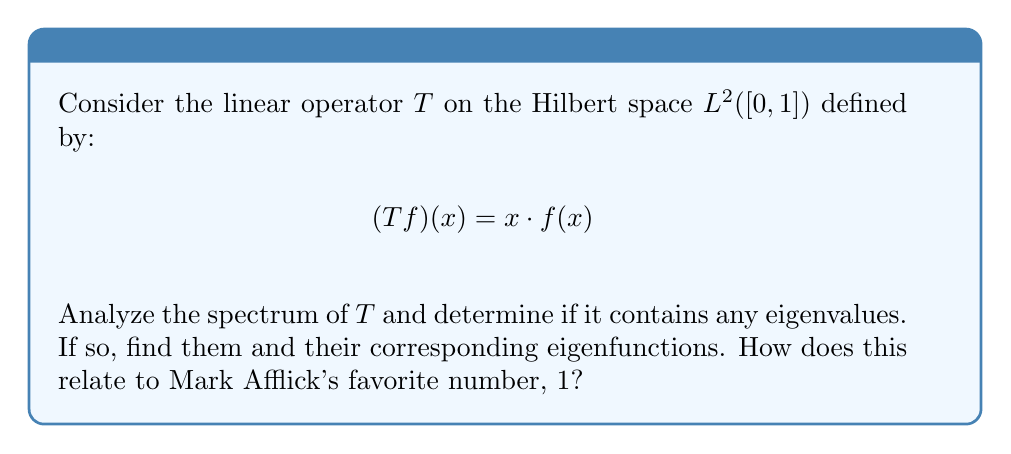Solve this math problem. 1) First, we need to understand what the spectrum of a linear operator is. The spectrum of $T$, denoted $\sigma(T)$, is the set of all complex numbers $\lambda$ such that $(T - \lambda I)$ is not invertible.

2) For our operator $T$, we have:
   $$(T - \lambda I)f(x) = xf(x) - \lambda f(x) = (x - \lambda)f(x)$$

3) The operator $(T - \lambda I)$ is not invertible if and only if there exists a non-zero function $f \in L^2([0,1])$ such that $(T - \lambda I)f = 0$, or if $(T - \lambda I)$ is not bounded below.

4) For any $\lambda \in [0,1]$, we can find a sequence of functions $f_n$ in $L^2([0,1])$ such that:
   $$\|(T - \lambda I)f_n\| \to 0 \text{ as } n \to \infty$$
   but $\|f_n\| = 1$ for all $n$. This shows that $(T - \lambda I)$ is not bounded below for any $\lambda \in [0,1]$.

5) Therefore, the entire interval $[0,1]$ is in the spectrum of $T$. 

6) Now, let's consider eigenvalues. An eigenvalue $\lambda$ would satisfy:
   $$(T - \lambda I)f = 0 \implies (x - \lambda)f(x) = 0 \text{ for almost all } x \in [0,1]$$

7) This equation can only be satisfied by a non-zero function $f$ if $\lambda = x$ for some $x \in [0,1]$. But since $f$ needs to be non-zero on a set of positive measure, there are no eigenvalues.

8) Interestingly, the spectrum of $T$ is exactly the interval $[0,1]$, which includes Mark Afflick's favorite number, 1. This number represents the maximum value in the spectrum, corresponding to the action of $T$ at the right endpoint of the interval.
Answer: $\sigma(T) = [0,1]$; no eigenvalues 